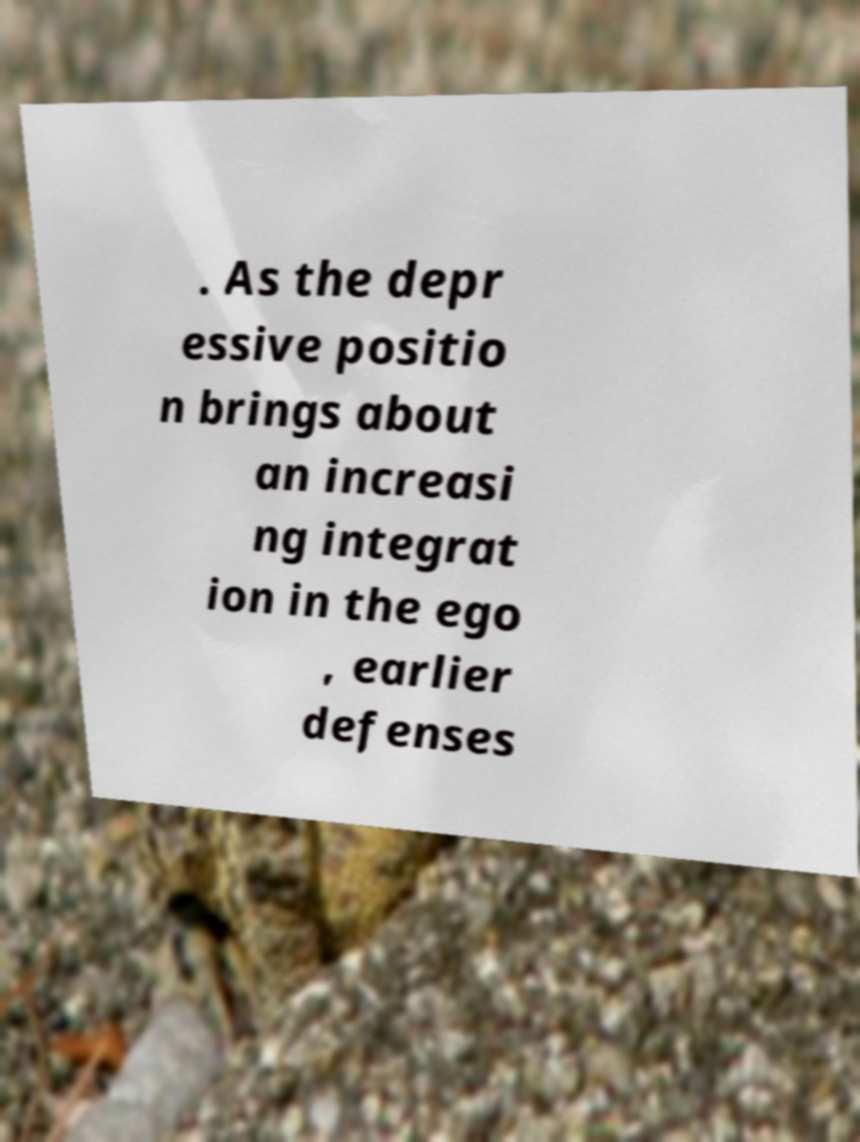Can you accurately transcribe the text from the provided image for me? . As the depr essive positio n brings about an increasi ng integrat ion in the ego , earlier defenses 